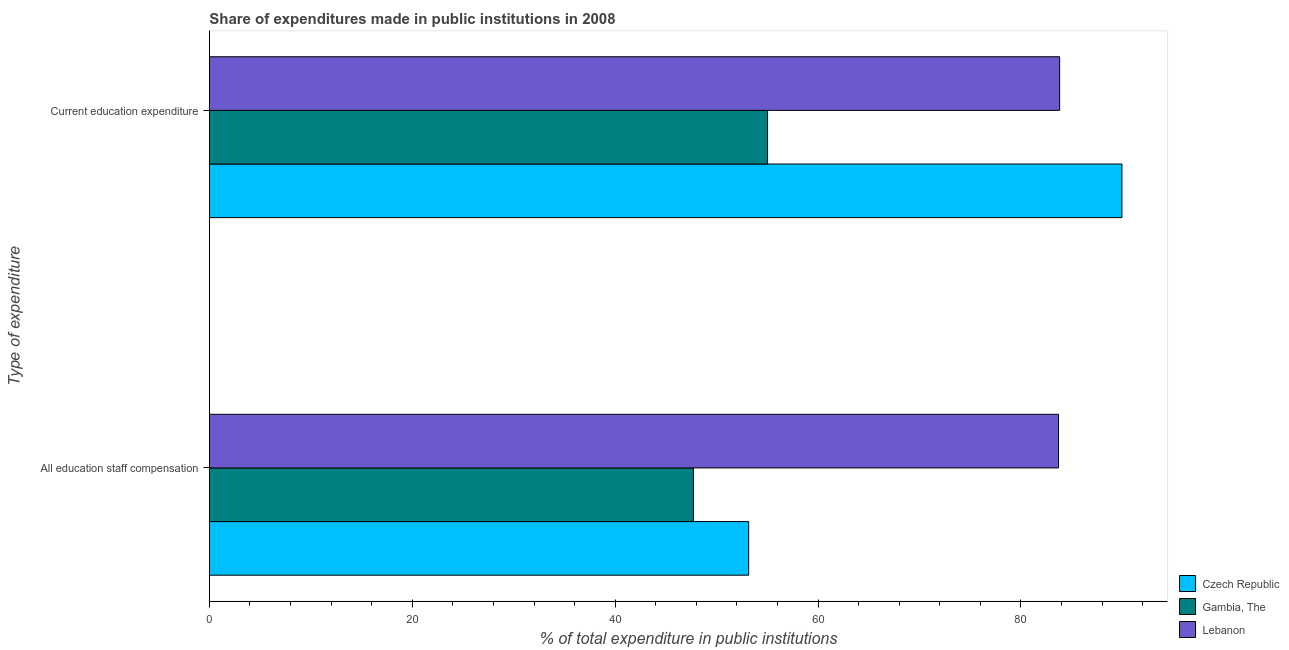How many different coloured bars are there?
Your response must be concise. 3. Are the number of bars per tick equal to the number of legend labels?
Provide a succinct answer. Yes. How many bars are there on the 1st tick from the top?
Your answer should be very brief. 3. What is the label of the 2nd group of bars from the top?
Keep it short and to the point. All education staff compensation. What is the expenditure in education in Lebanon?
Your response must be concise. 83.82. Across all countries, what is the maximum expenditure in education?
Your answer should be very brief. 89.96. Across all countries, what is the minimum expenditure in education?
Provide a short and direct response. 55.02. In which country was the expenditure in staff compensation maximum?
Offer a very short reply. Lebanon. In which country was the expenditure in education minimum?
Keep it short and to the point. Gambia, The. What is the total expenditure in staff compensation in the graph?
Give a very brief answer. 184.58. What is the difference between the expenditure in staff compensation in Czech Republic and that in Lebanon?
Your response must be concise. -30.55. What is the difference between the expenditure in staff compensation in Czech Republic and the expenditure in education in Gambia, The?
Ensure brevity in your answer.  -1.86. What is the average expenditure in staff compensation per country?
Ensure brevity in your answer.  61.53. What is the difference between the expenditure in staff compensation and expenditure in education in Czech Republic?
Provide a succinct answer. -36.79. What is the ratio of the expenditure in education in Lebanon to that in Gambia, The?
Your answer should be very brief. 1.52. Is the expenditure in education in Czech Republic less than that in Gambia, The?
Make the answer very short. No. What does the 1st bar from the top in All education staff compensation represents?
Your response must be concise. Lebanon. What does the 3rd bar from the bottom in All education staff compensation represents?
Make the answer very short. Lebanon. Are all the bars in the graph horizontal?
Offer a very short reply. Yes. How many countries are there in the graph?
Give a very brief answer. 3. Does the graph contain any zero values?
Offer a terse response. No. Where does the legend appear in the graph?
Your response must be concise. Bottom right. What is the title of the graph?
Make the answer very short. Share of expenditures made in public institutions in 2008. What is the label or title of the X-axis?
Offer a very short reply. % of total expenditure in public institutions. What is the label or title of the Y-axis?
Make the answer very short. Type of expenditure. What is the % of total expenditure in public institutions in Czech Republic in All education staff compensation?
Give a very brief answer. 53.16. What is the % of total expenditure in public institutions in Gambia, The in All education staff compensation?
Give a very brief answer. 47.71. What is the % of total expenditure in public institutions in Lebanon in All education staff compensation?
Your response must be concise. 83.71. What is the % of total expenditure in public institutions in Czech Republic in Current education expenditure?
Offer a terse response. 89.96. What is the % of total expenditure in public institutions of Gambia, The in Current education expenditure?
Your response must be concise. 55.02. What is the % of total expenditure in public institutions of Lebanon in Current education expenditure?
Your answer should be very brief. 83.82. Across all Type of expenditure, what is the maximum % of total expenditure in public institutions in Czech Republic?
Ensure brevity in your answer.  89.96. Across all Type of expenditure, what is the maximum % of total expenditure in public institutions in Gambia, The?
Provide a succinct answer. 55.02. Across all Type of expenditure, what is the maximum % of total expenditure in public institutions of Lebanon?
Offer a terse response. 83.82. Across all Type of expenditure, what is the minimum % of total expenditure in public institutions in Czech Republic?
Offer a terse response. 53.16. Across all Type of expenditure, what is the minimum % of total expenditure in public institutions in Gambia, The?
Offer a very short reply. 47.71. Across all Type of expenditure, what is the minimum % of total expenditure in public institutions in Lebanon?
Offer a terse response. 83.71. What is the total % of total expenditure in public institutions in Czech Republic in the graph?
Your answer should be compact. 143.12. What is the total % of total expenditure in public institutions in Gambia, The in the graph?
Your response must be concise. 102.74. What is the total % of total expenditure in public institutions in Lebanon in the graph?
Offer a very short reply. 167.52. What is the difference between the % of total expenditure in public institutions of Czech Republic in All education staff compensation and that in Current education expenditure?
Offer a terse response. -36.79. What is the difference between the % of total expenditure in public institutions of Gambia, The in All education staff compensation and that in Current education expenditure?
Your answer should be very brief. -7.31. What is the difference between the % of total expenditure in public institutions in Lebanon in All education staff compensation and that in Current education expenditure?
Provide a succinct answer. -0.11. What is the difference between the % of total expenditure in public institutions in Czech Republic in All education staff compensation and the % of total expenditure in public institutions in Gambia, The in Current education expenditure?
Keep it short and to the point. -1.86. What is the difference between the % of total expenditure in public institutions of Czech Republic in All education staff compensation and the % of total expenditure in public institutions of Lebanon in Current education expenditure?
Offer a terse response. -30.66. What is the difference between the % of total expenditure in public institutions in Gambia, The in All education staff compensation and the % of total expenditure in public institutions in Lebanon in Current education expenditure?
Give a very brief answer. -36.1. What is the average % of total expenditure in public institutions in Czech Republic per Type of expenditure?
Keep it short and to the point. 71.56. What is the average % of total expenditure in public institutions of Gambia, The per Type of expenditure?
Offer a very short reply. 51.37. What is the average % of total expenditure in public institutions of Lebanon per Type of expenditure?
Offer a terse response. 83.76. What is the difference between the % of total expenditure in public institutions in Czech Republic and % of total expenditure in public institutions in Gambia, The in All education staff compensation?
Ensure brevity in your answer.  5.45. What is the difference between the % of total expenditure in public institutions in Czech Republic and % of total expenditure in public institutions in Lebanon in All education staff compensation?
Make the answer very short. -30.55. What is the difference between the % of total expenditure in public institutions in Gambia, The and % of total expenditure in public institutions in Lebanon in All education staff compensation?
Your answer should be compact. -35.99. What is the difference between the % of total expenditure in public institutions in Czech Republic and % of total expenditure in public institutions in Gambia, The in Current education expenditure?
Offer a very short reply. 34.93. What is the difference between the % of total expenditure in public institutions in Czech Republic and % of total expenditure in public institutions in Lebanon in Current education expenditure?
Make the answer very short. 6.14. What is the difference between the % of total expenditure in public institutions in Gambia, The and % of total expenditure in public institutions in Lebanon in Current education expenditure?
Provide a succinct answer. -28.79. What is the ratio of the % of total expenditure in public institutions of Czech Republic in All education staff compensation to that in Current education expenditure?
Provide a short and direct response. 0.59. What is the ratio of the % of total expenditure in public institutions of Gambia, The in All education staff compensation to that in Current education expenditure?
Ensure brevity in your answer.  0.87. What is the difference between the highest and the second highest % of total expenditure in public institutions of Czech Republic?
Keep it short and to the point. 36.79. What is the difference between the highest and the second highest % of total expenditure in public institutions of Gambia, The?
Give a very brief answer. 7.31. What is the difference between the highest and the second highest % of total expenditure in public institutions in Lebanon?
Give a very brief answer. 0.11. What is the difference between the highest and the lowest % of total expenditure in public institutions in Czech Republic?
Your answer should be very brief. 36.79. What is the difference between the highest and the lowest % of total expenditure in public institutions in Gambia, The?
Offer a very short reply. 7.31. What is the difference between the highest and the lowest % of total expenditure in public institutions of Lebanon?
Make the answer very short. 0.11. 